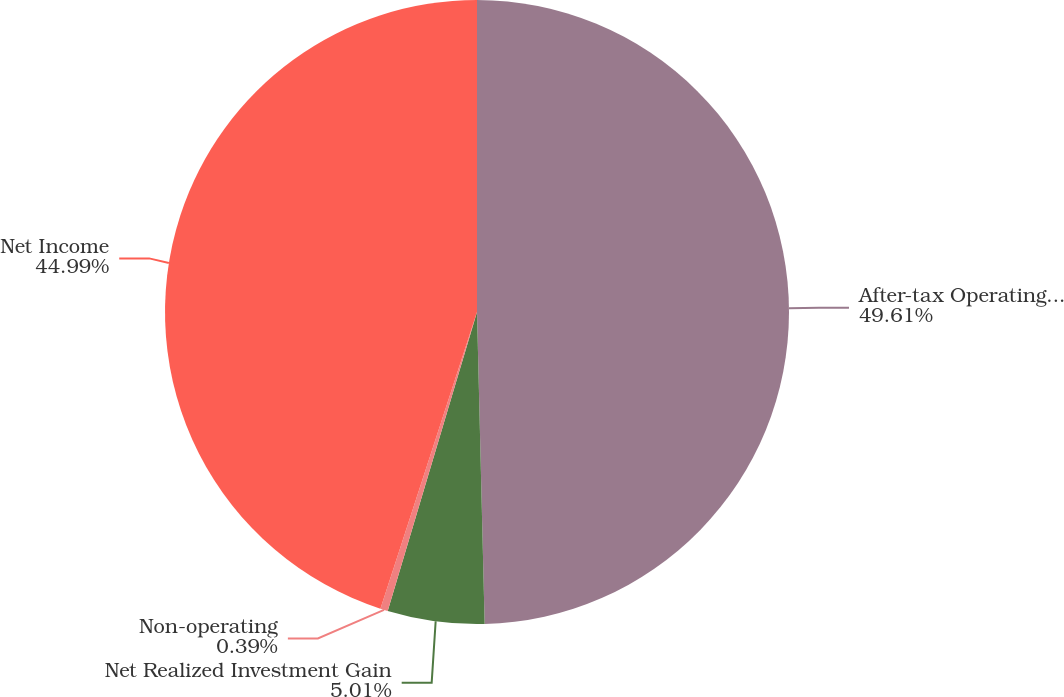Convert chart. <chart><loc_0><loc_0><loc_500><loc_500><pie_chart><fcel>After-tax Operating Income<fcel>Net Realized Investment Gain<fcel>Non-operating<fcel>Net Income<nl><fcel>49.61%<fcel>5.01%<fcel>0.39%<fcel>44.99%<nl></chart> 